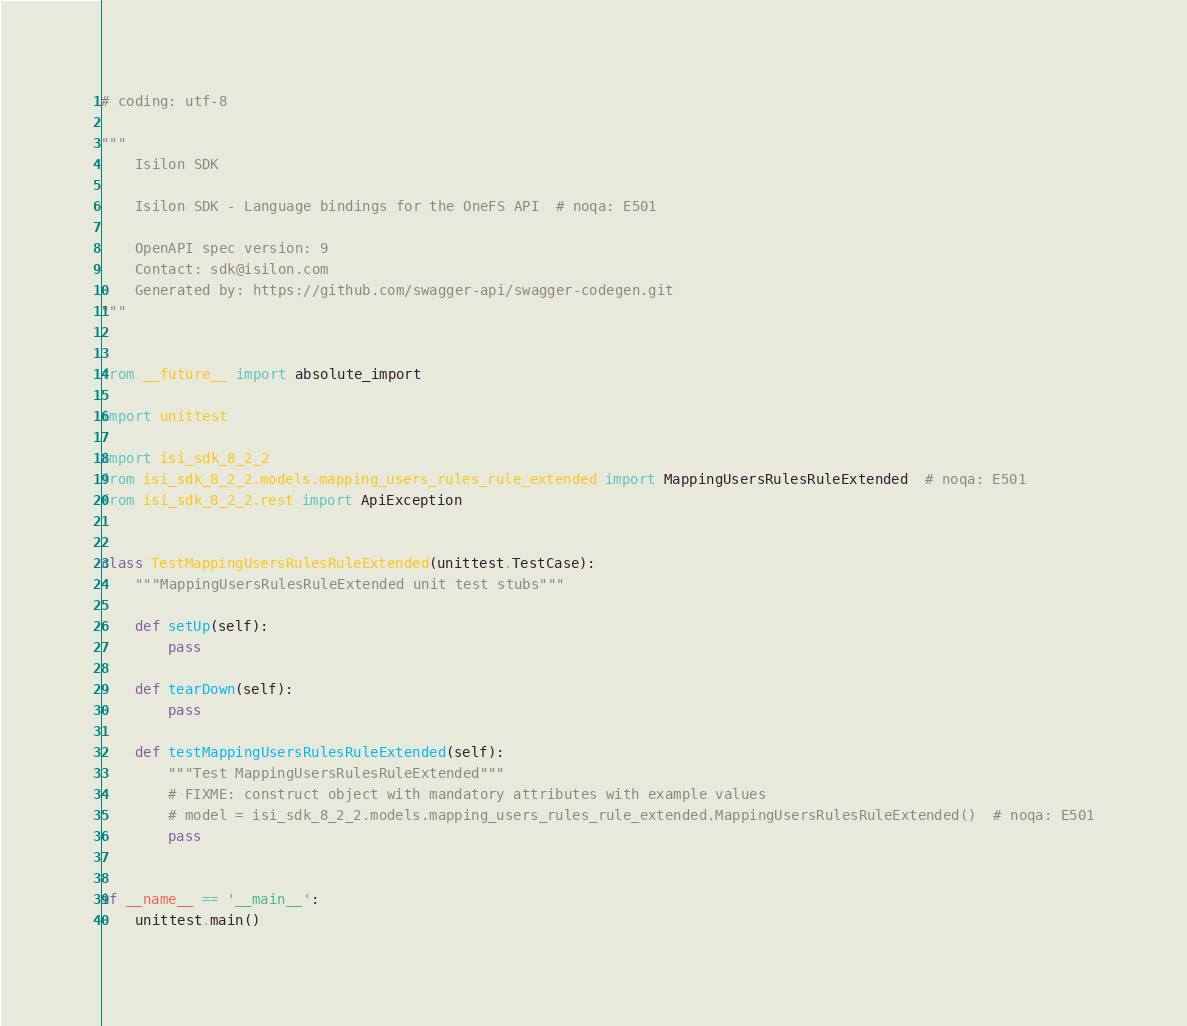Convert code to text. <code><loc_0><loc_0><loc_500><loc_500><_Python_># coding: utf-8

"""
    Isilon SDK

    Isilon SDK - Language bindings for the OneFS API  # noqa: E501

    OpenAPI spec version: 9
    Contact: sdk@isilon.com
    Generated by: https://github.com/swagger-api/swagger-codegen.git
"""


from __future__ import absolute_import

import unittest

import isi_sdk_8_2_2
from isi_sdk_8_2_2.models.mapping_users_rules_rule_extended import MappingUsersRulesRuleExtended  # noqa: E501
from isi_sdk_8_2_2.rest import ApiException


class TestMappingUsersRulesRuleExtended(unittest.TestCase):
    """MappingUsersRulesRuleExtended unit test stubs"""

    def setUp(self):
        pass

    def tearDown(self):
        pass

    def testMappingUsersRulesRuleExtended(self):
        """Test MappingUsersRulesRuleExtended"""
        # FIXME: construct object with mandatory attributes with example values
        # model = isi_sdk_8_2_2.models.mapping_users_rules_rule_extended.MappingUsersRulesRuleExtended()  # noqa: E501
        pass


if __name__ == '__main__':
    unittest.main()
</code> 